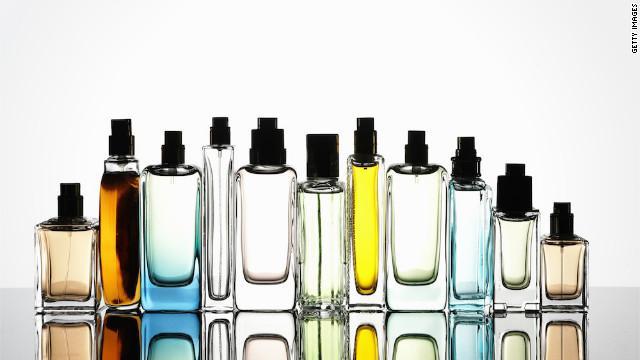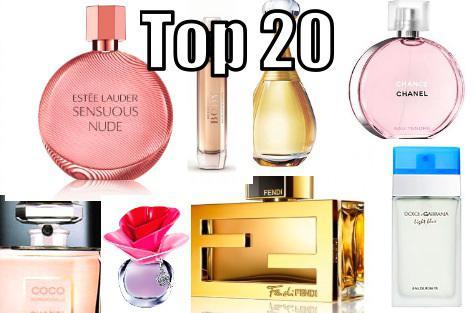The first image is the image on the left, the second image is the image on the right. Assess this claim about the two images: "In one of the images, there is no lettering on any of the perfume bottles.". Correct or not? Answer yes or no. Yes. The first image is the image on the left, the second image is the image on the right. Analyze the images presented: Is the assertion "One image contains eight fragrance bottles in various shapes and colors, including one purplish bottle topped with a rose shape." valid? Answer yes or no. Yes. 